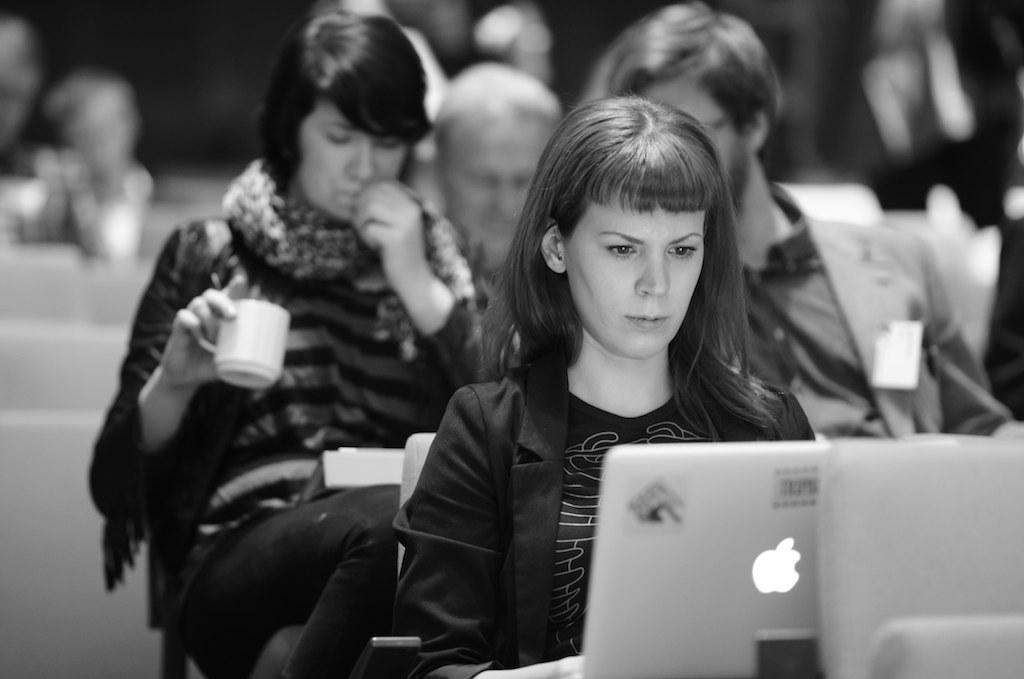Could you give a brief overview of what you see in this image? Here in the front we can see a woman sitting on a chair with a laptop in front of her and behind her we can see number of people sitting on chairs with coffee cups and books with them. 